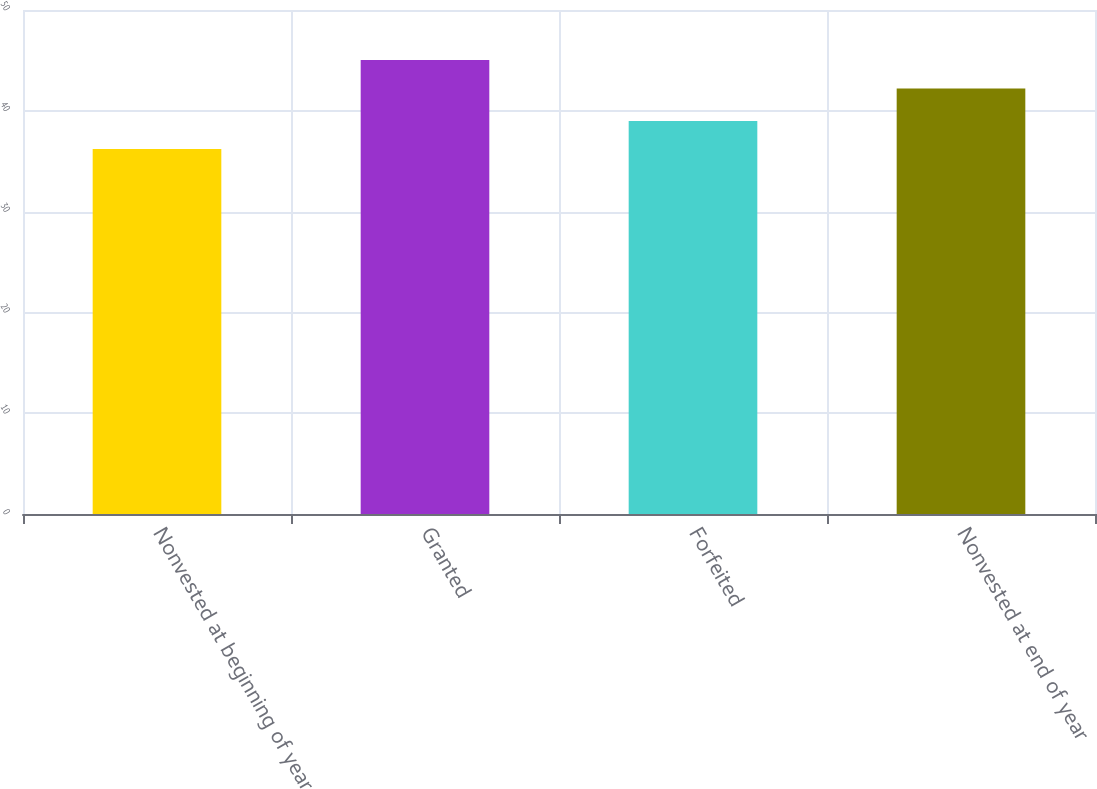<chart> <loc_0><loc_0><loc_500><loc_500><bar_chart><fcel>Nonvested at beginning of year<fcel>Granted<fcel>Forfeited<fcel>Nonvested at end of year<nl><fcel>36.2<fcel>45.05<fcel>39<fcel>42.22<nl></chart> 